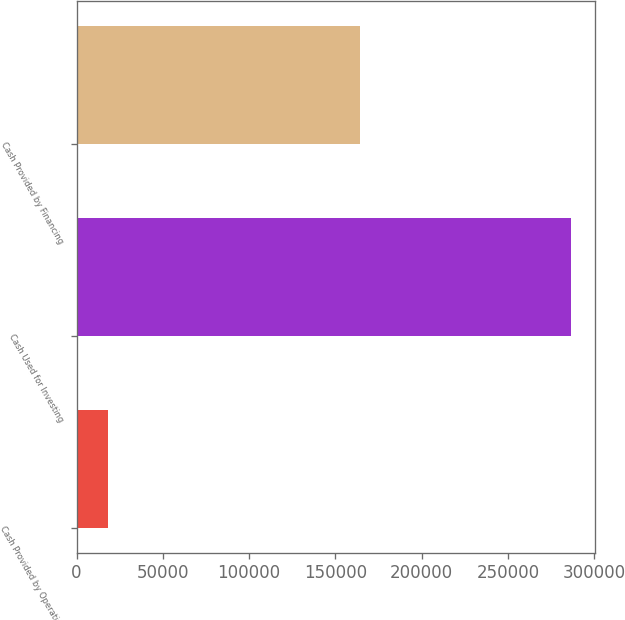Convert chart to OTSL. <chart><loc_0><loc_0><loc_500><loc_500><bar_chart><fcel>Cash Provided by Operating<fcel>Cash Used for Investing<fcel>Cash Provided by Financing<nl><fcel>17977<fcel>286339<fcel>164218<nl></chart> 